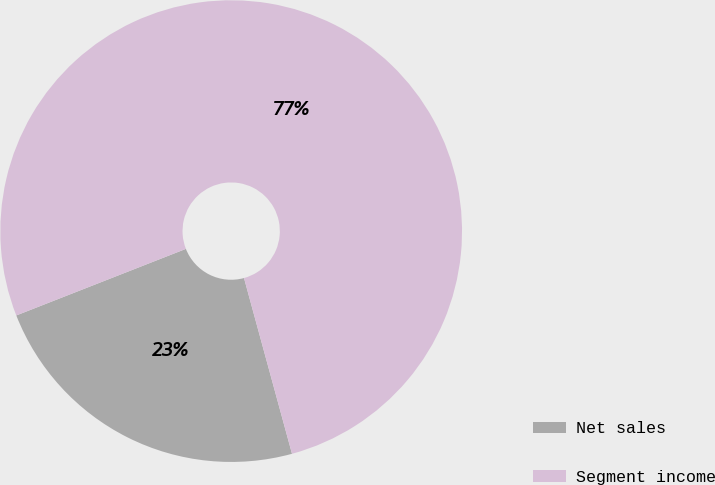<chart> <loc_0><loc_0><loc_500><loc_500><pie_chart><fcel>Net sales<fcel>Segment income<nl><fcel>23.29%<fcel>76.71%<nl></chart> 